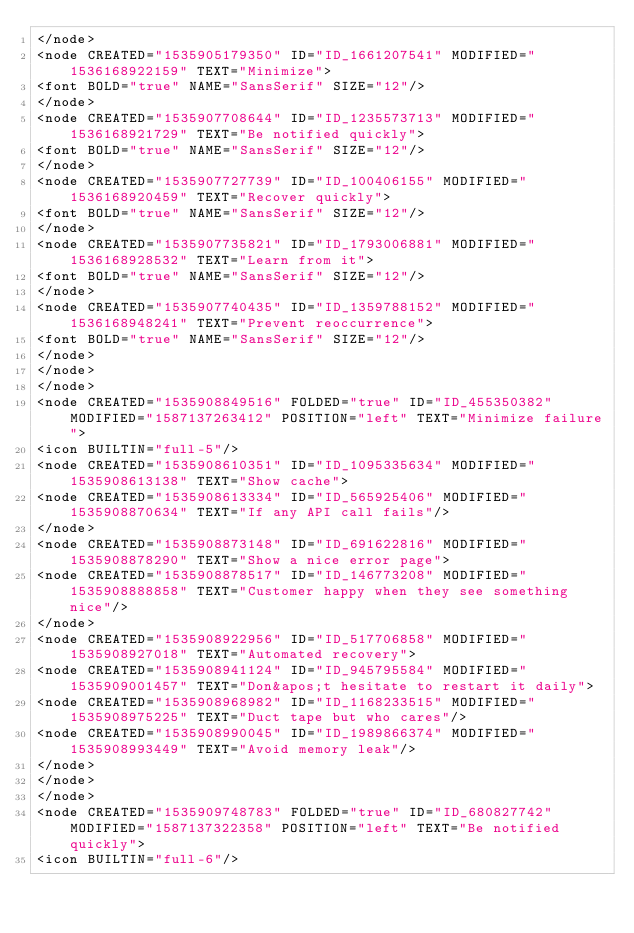Convert code to text. <code><loc_0><loc_0><loc_500><loc_500><_ObjectiveC_></node>
<node CREATED="1535905179350" ID="ID_1661207541" MODIFIED="1536168922159" TEXT="Minimize">
<font BOLD="true" NAME="SansSerif" SIZE="12"/>
</node>
<node CREATED="1535907708644" ID="ID_1235573713" MODIFIED="1536168921729" TEXT="Be notified quickly">
<font BOLD="true" NAME="SansSerif" SIZE="12"/>
</node>
<node CREATED="1535907727739" ID="ID_100406155" MODIFIED="1536168920459" TEXT="Recover quickly">
<font BOLD="true" NAME="SansSerif" SIZE="12"/>
</node>
<node CREATED="1535907735821" ID="ID_1793006881" MODIFIED="1536168928532" TEXT="Learn from it">
<font BOLD="true" NAME="SansSerif" SIZE="12"/>
</node>
<node CREATED="1535907740435" ID="ID_1359788152" MODIFIED="1536168948241" TEXT="Prevent reoccurrence">
<font BOLD="true" NAME="SansSerif" SIZE="12"/>
</node>
</node>
</node>
<node CREATED="1535908849516" FOLDED="true" ID="ID_455350382" MODIFIED="1587137263412" POSITION="left" TEXT="Minimize failure">
<icon BUILTIN="full-5"/>
<node CREATED="1535908610351" ID="ID_1095335634" MODIFIED="1535908613138" TEXT="Show cache">
<node CREATED="1535908613334" ID="ID_565925406" MODIFIED="1535908870634" TEXT="If any API call fails"/>
</node>
<node CREATED="1535908873148" ID="ID_691622816" MODIFIED="1535908878290" TEXT="Show a nice error page">
<node CREATED="1535908878517" ID="ID_146773208" MODIFIED="1535908888858" TEXT="Customer happy when they see something nice"/>
</node>
<node CREATED="1535908922956" ID="ID_517706858" MODIFIED="1535908927018" TEXT="Automated recovery">
<node CREATED="1535908941124" ID="ID_945795584" MODIFIED="1535909001457" TEXT="Don&apos;t hesitate to restart it daily">
<node CREATED="1535908968982" ID="ID_1168233515" MODIFIED="1535908975225" TEXT="Duct tape but who cares"/>
<node CREATED="1535908990045" ID="ID_1989866374" MODIFIED="1535908993449" TEXT="Avoid memory leak"/>
</node>
</node>
</node>
<node CREATED="1535909748783" FOLDED="true" ID="ID_680827742" MODIFIED="1587137322358" POSITION="left" TEXT="Be notified quickly">
<icon BUILTIN="full-6"/></code> 